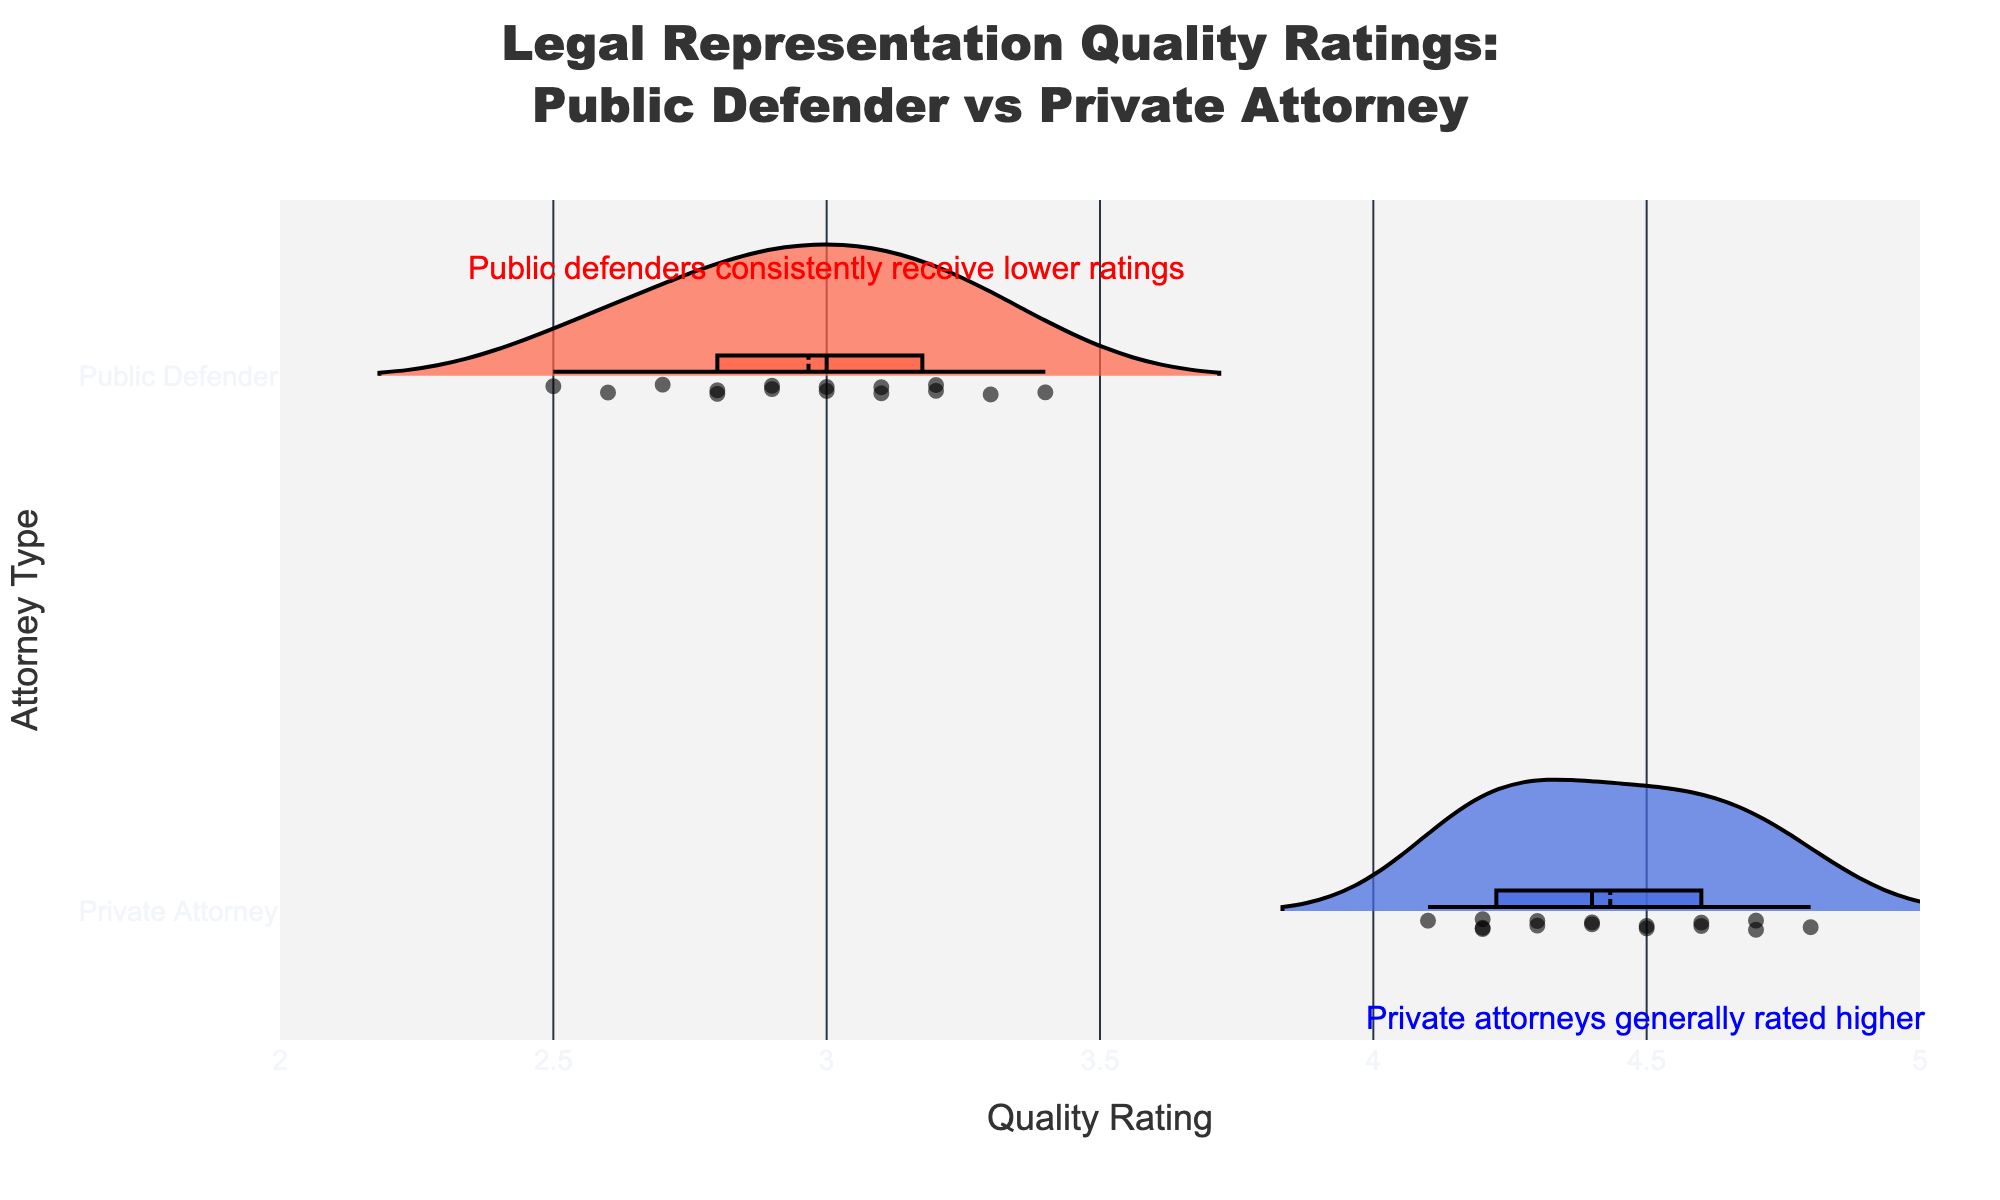what is the title of the chart? The title is placed prominently at the top center of the chart. It reads "Legal Representation Quality Ratings: Public Defender vs Private Attorney". Just look at the top of the chart to find it.
Answer: "Legal Representation Quality Ratings: Public Defender vs Private Attorney" What axis title represents the rating scale? The x-axis represents the quality rating scale. You can see "Quality Rating" written along the horizontal axis, which indicates the ratings of the attorneys.
Answer: Quality Rating What colors are used to differentiate between Public Defenders and Private Attorneys? The Public Defenders are represented by a reddish-orange color, while the Private Attorneys are represented by a blue color. This can be seen from the fill colors of the violin plots and their annotations.
Answer: reddish-orange & blue How many data points are there for Public Defenders? By counting each point within the reddish-orange violin plot, it's clear that there are 15 individual data points for Public Defenders.
Answer: 15 What is the mean Quality Rating for Private Attorneys? To find the mean, look at the mean line visible on the blue violin plot for Private Attorneys. It appears around the 4.4 mark on the x-axis.
Answer: approximately 4.4 What is the range of Quality Ratings for Public Defenders? The range of Quality Ratings for Public Defenders extends from the lowest rating of 2.5 to the highest rating of 3.4. Check the spread of the reddish-orange violin plot to determine this.
Answer: 2.5 to 3.4 Who generally has higher-quality ratings, Public Defenders or Private Attorneys? By comparing the two violin plots, it's clear that Private Attorneys generally have higher-quality ratings than Public Defenders because their ratings are higher on the x-axis.
Answer: Private Attorneys What does the annotation at 3.0 on the x-axis and 1.2 on the y-axis indicate? The annotation at these coordinates states, "Public defenders consistently receive lower ratings", highlighting the trend observed in the reddish-orange violin plot.
Answer: Public defenders consistently receive lower ratings Compare the variability of Quality Ratings between Public Defenders and Private Attorneys? The violin plot for Public Defenders is narrower and more concentrated, indicating less variability. In contrast, Private Attorneys show a broader spread, suggesting higher variability within their ratings.
Answer: More variability for Private Attorneys 